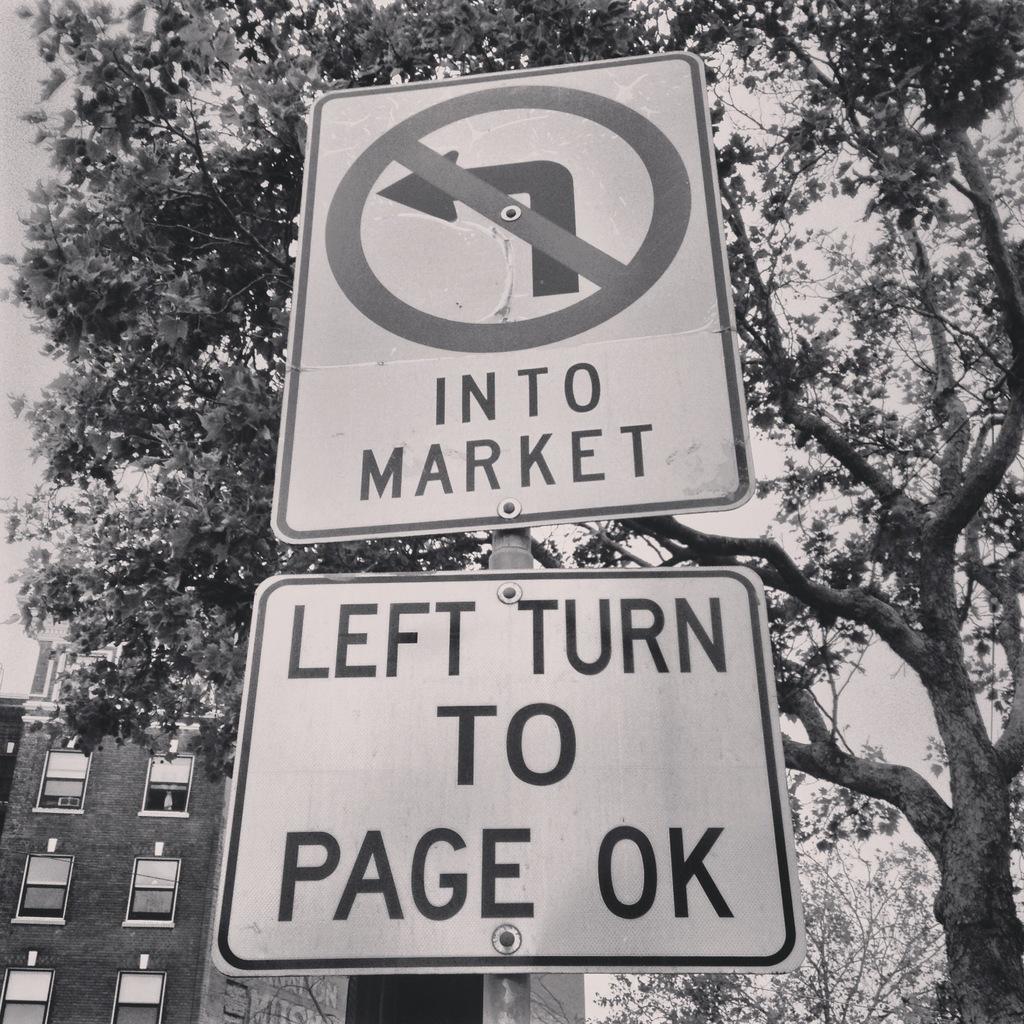How would you summarize this image in a sentence or two? In this image we can see two sign to the pole, on the right side there are trees and a building on the left side and sky in the background. 